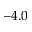<formula> <loc_0><loc_0><loc_500><loc_500>- 4 . 0</formula> 